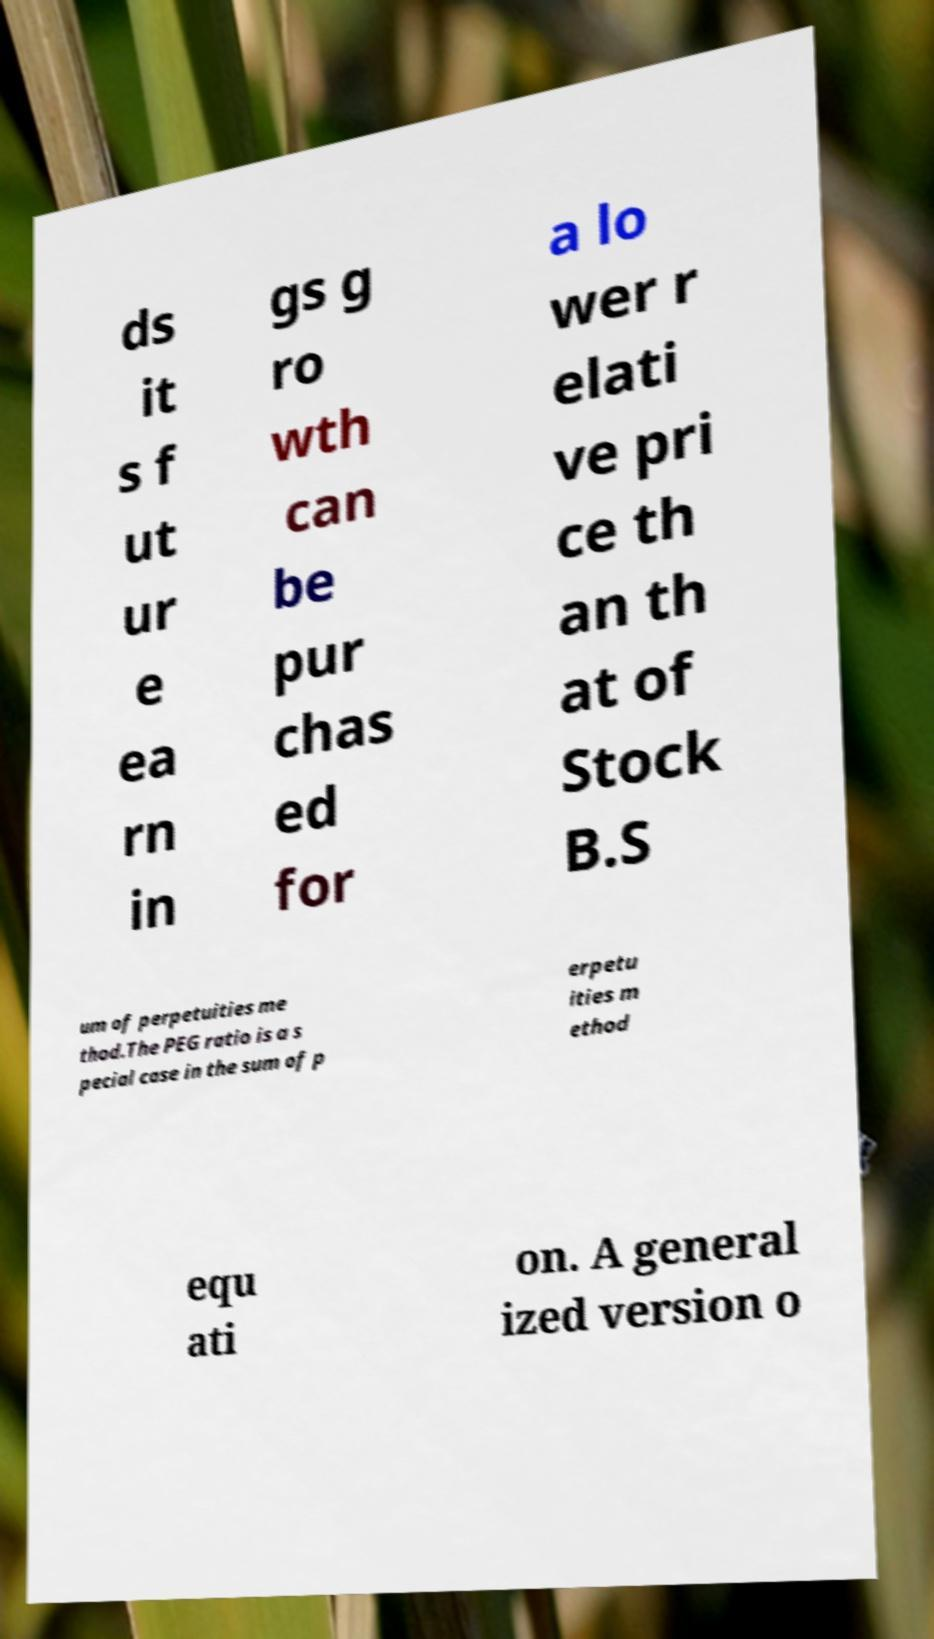Could you assist in decoding the text presented in this image and type it out clearly? ds it s f ut ur e ea rn in gs g ro wth can be pur chas ed for a lo wer r elati ve pri ce th an th at of Stock B.S um of perpetuities me thod.The PEG ratio is a s pecial case in the sum of p erpetu ities m ethod equ ati on. A general ized version o 